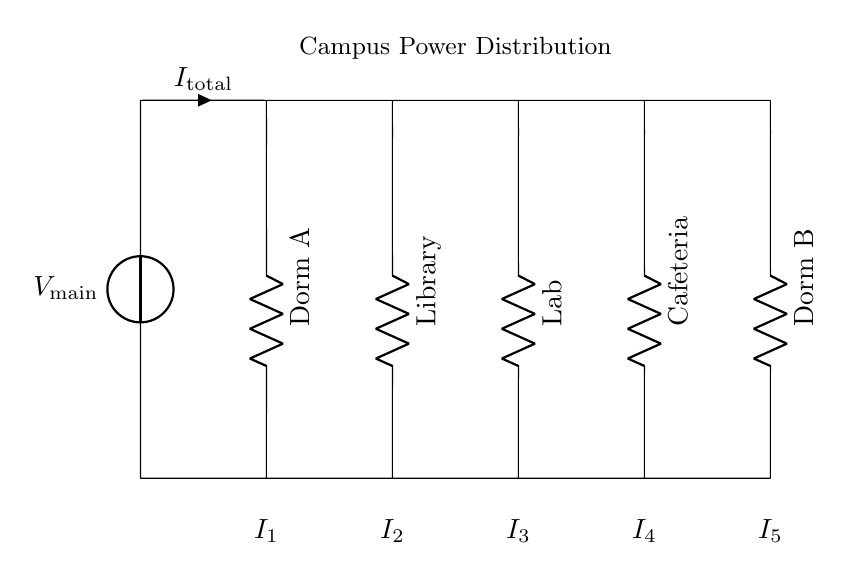What is the total current in this circuit? The total current, denoted as I_total, is the sum of the individual branch currents and can be observed directly as the current flowing from the main voltage source into the circuit.
Answer: I_total What components are shown in this circuit? The circuit contains a voltage source and several resistors, each representing a different load such as Dorm A, the Library, the Lab, the Cafeteria, and Dorm B.
Answer: Voltage source and resistors How many branches are in this parallel circuit? The circuit has five branches, each corresponding to individual loads connected parallel to the main voltage source.
Answer: Five Which load has the highest resistance? Based on the visual representation, the loads are not directly labeled with values; however, typically, if there were a visible label indicating resistance, identifying it would require the values. Since no values are provided, the answer is based on hypothetical comparisons.
Answer: Not determinable from the diagram If the main voltage is 120 volts, what voltage does each load receive? In a parallel circuit, each load receives the same voltage as the main source, which means every branch receives the full voltage supplied by the voltage source. Thus, if the main voltage is 120 volts, each load also receives 120 volts.
Answer: 120 volts What is the significance of the current labels (I1, I2, I3, I4, I5) beneath the loads? The labels I1 to I5 indicate the individual currents flowing through each branch connected to the respective loads. Each current represents the flow of electrical charge due to the resistance of its load.
Answer: Individual branch currents Which load is connected to the second branch from the left? By examining the circuit diagram, we identify that the second load from the left is the Library, which corresponds to the branch labeled accordingly.
Answer: Library 